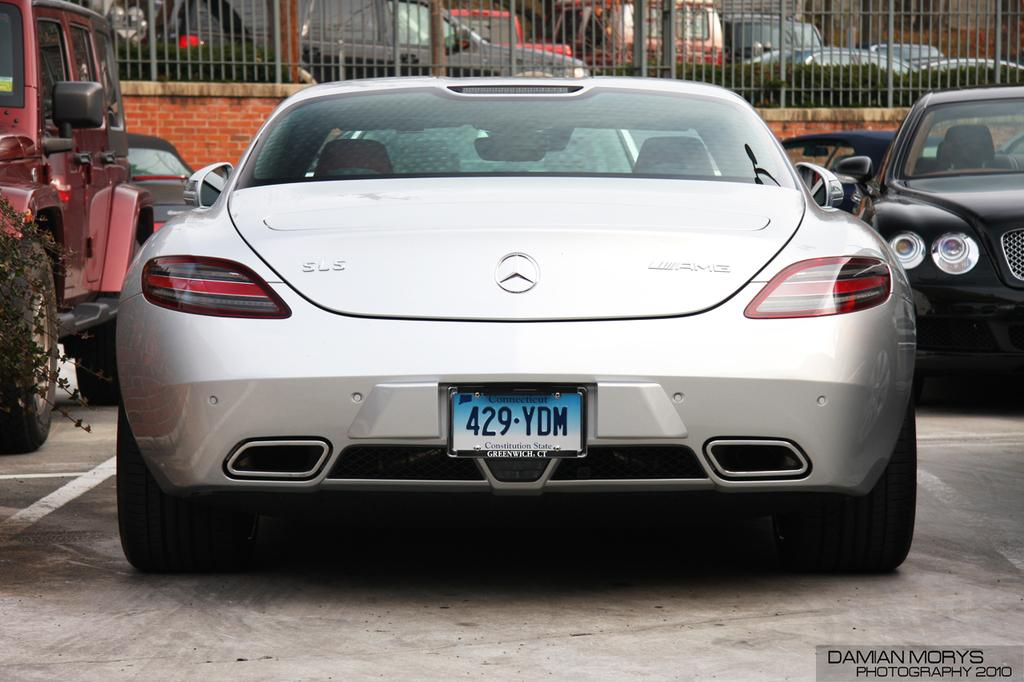What can be seen in large numbers in the image? There are many vehicles in the image. What type of barrier is present in the image? There is a fencing in the image. What type of natural elements are visible in the image? There are many plants in the image. What type of bone can be seen in the image? There is no bone present in the image. What type of screw is visible in the image? There is no screw present in the image. 